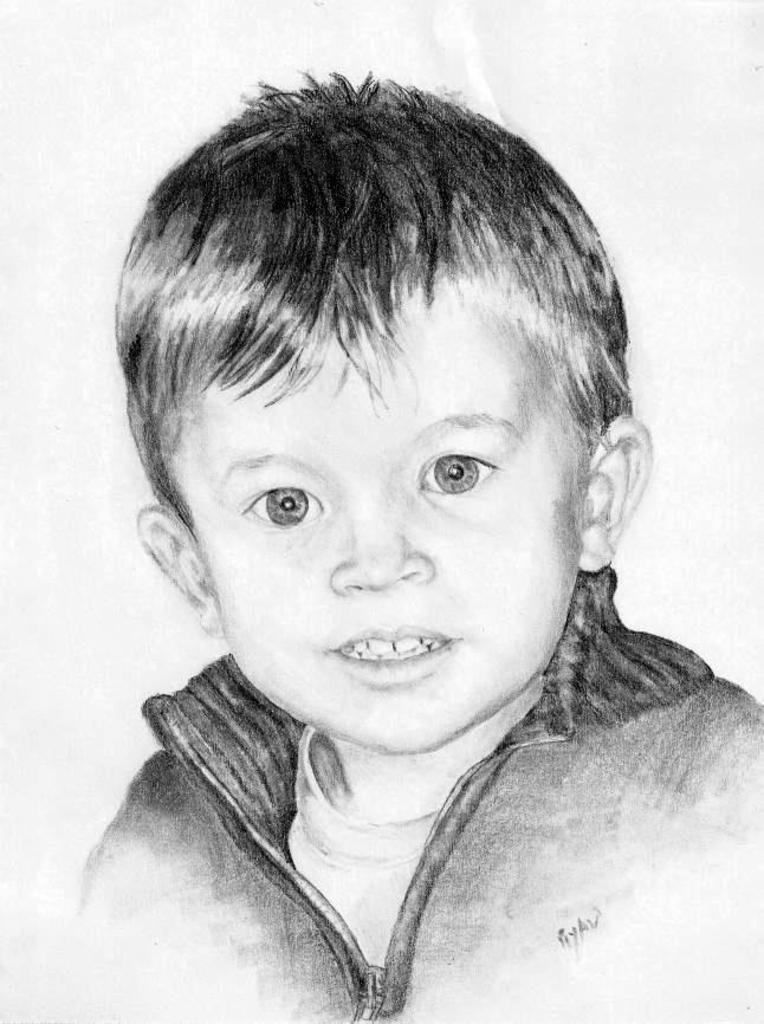What is the main subject of the image? The main subject of the image is a picture of a kid. Can you describe the kid in the image? Unfortunately, the provided facts do not include any details about the appearance or actions of the kid in the image. What type of stew is being served at the event in the image? There is no event or stew present in the image; it only features a picture of a kid. What invention is the kid holding in the image? There is no invention visible in the image; it only features a picture of a kid. 